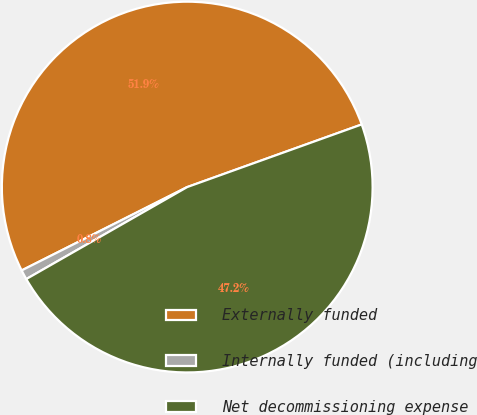Convert chart. <chart><loc_0><loc_0><loc_500><loc_500><pie_chart><fcel>Externally funded<fcel>Internally funded (including<fcel>Net decommissioning expense<nl><fcel>51.94%<fcel>0.84%<fcel>47.22%<nl></chart> 